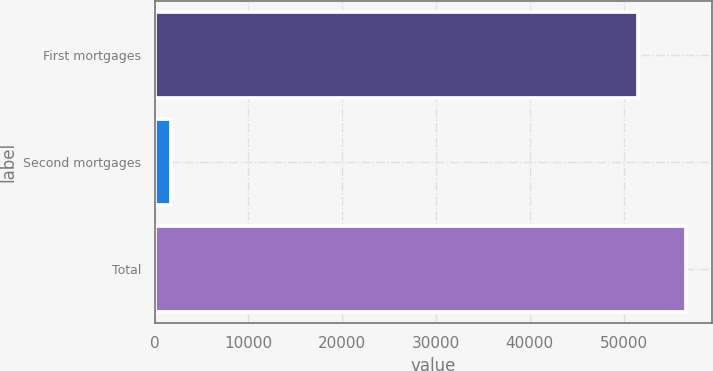Convert chart. <chart><loc_0><loc_0><loc_500><loc_500><bar_chart><fcel>First mortgages<fcel>Second mortgages<fcel>Total<nl><fcel>51495<fcel>1752<fcel>56644.5<nl></chart> 